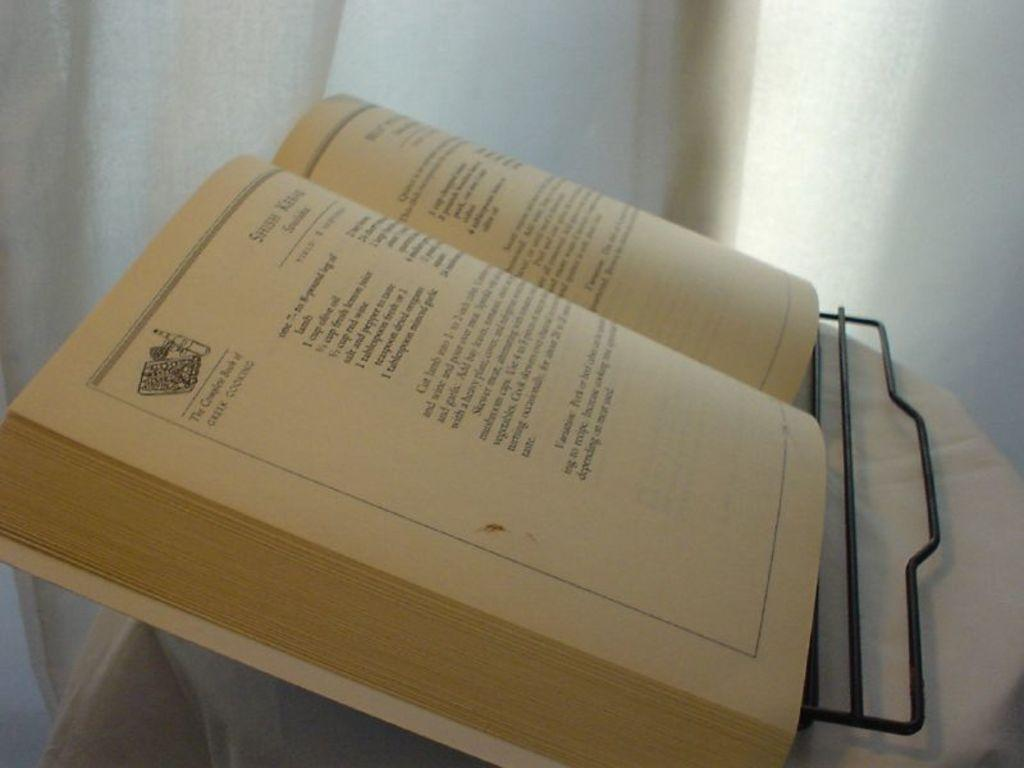What object can be seen in the image related to reading or learning? There is a book in the image. What other object is present in the image that is not related to reading or learning? There is a cloth in the image. What color is the background of the image? The background of the image is white. What type of stocking is hanging on the wall in the image? There is no stocking present in the image; it only features a book and a cloth. What is the tendency of the rake in the image? There is no rake present in the image, so it is not possible to determine its tendency. 